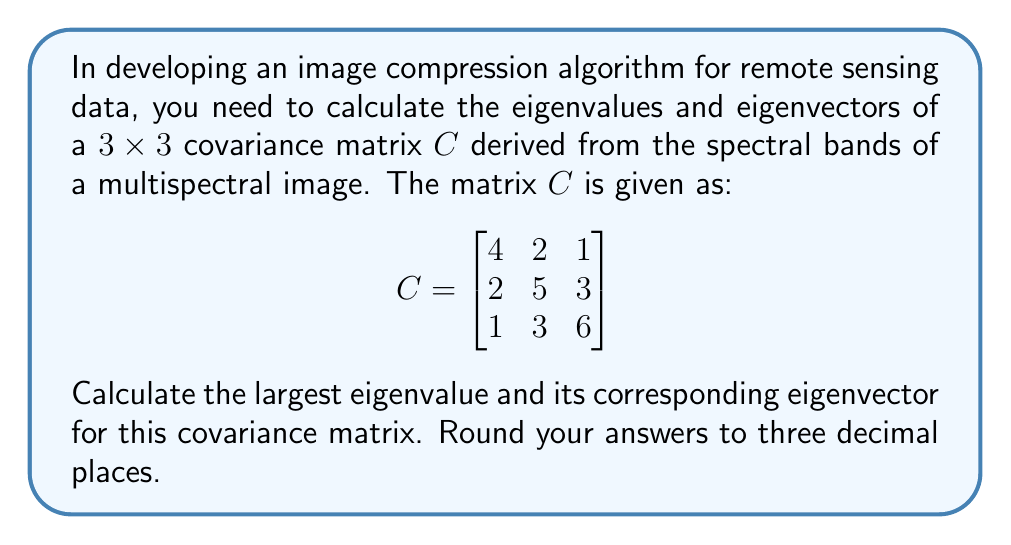Provide a solution to this math problem. To find the eigenvalues and eigenvectors, we follow these steps:

1) First, we need to find the characteristic equation:
   $det(C - \lambda I) = 0$

2) Expand the determinant:
   $$\begin{vmatrix}
   4-\lambda & 2 & 1 \\
   2 & 5-\lambda & 3 \\
   1 & 3 & 6-\lambda
   \end{vmatrix} = 0$$

3) Solve the resulting cubic equation:
   $-\lambda^3 + 15\lambda^2 - 59\lambda + 45 = 0$

4) Using a cubic equation solver or computer algebra system, we find the roots:
   $\lambda_1 \approx 8.898$, $\lambda_2 \approx 4.101$, $\lambda_3 \approx 2.001$

5) The largest eigenvalue is $\lambda_1 \approx 8.898$

6) To find the corresponding eigenvector, we solve $(C - \lambda_1 I)\vec{v} = \vec{0}$:

   $$\begin{bmatrix}
   -4.898 & 2 & 1 \\
   2 & -3.898 & 3 \\
   1 & 3 & -2.898
   \end{bmatrix}\begin{bmatrix}
   v_1 \\ v_2 \\ v_3
   \end{bmatrix} = \begin{bmatrix}
   0 \\ 0 \\ 0
   \end{bmatrix}$$

7) Solve this system of equations. One solution is:
   $v_1 \approx 0.418$, $v_2 \approx 0.606$, $v_3 \approx 0.677$

8) Normalize the eigenvector:
   $\sqrt{0.418^2 + 0.606^2 + 0.677^2} \approx 1$, so this is already normalized.
Answer: Largest eigenvalue: $8.898$
Corresponding eigenvector: $[0.418, 0.606, 0.677]$ 